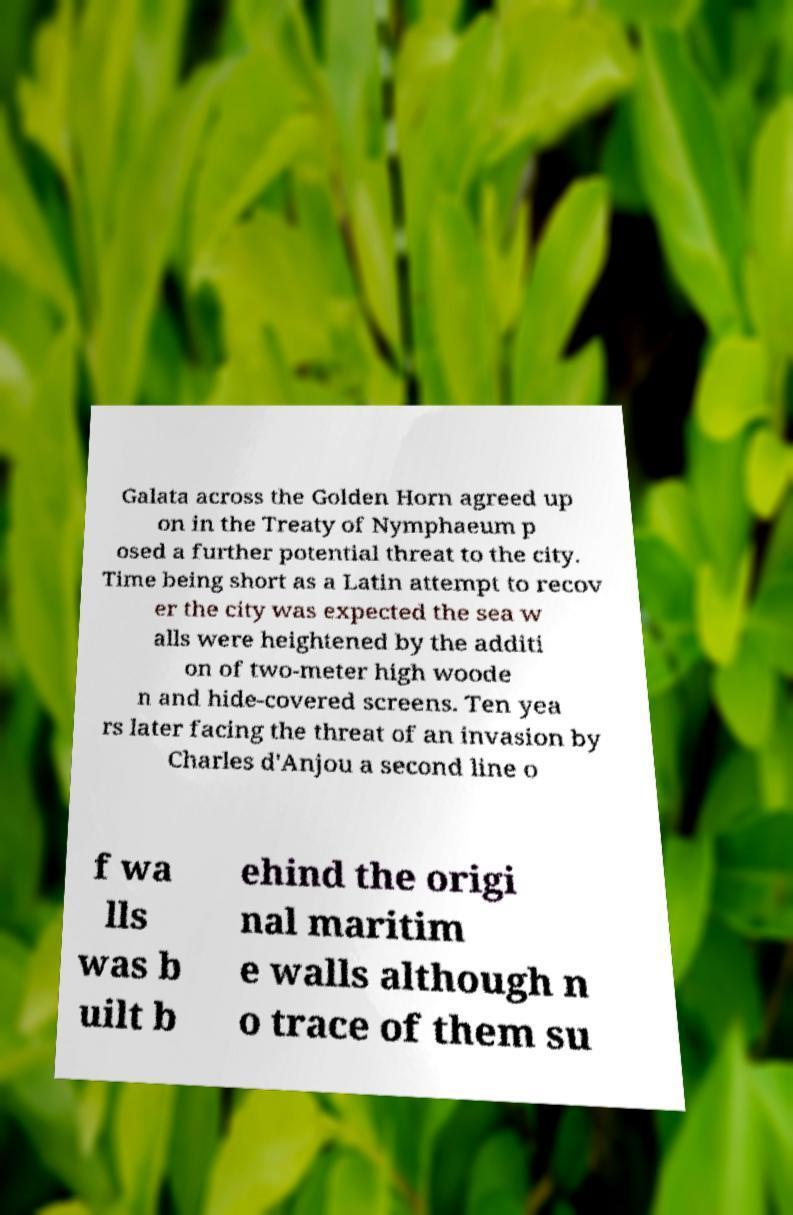I need the written content from this picture converted into text. Can you do that? Galata across the Golden Horn agreed up on in the Treaty of Nymphaeum p osed a further potential threat to the city. Time being short as a Latin attempt to recov er the city was expected the sea w alls were heightened by the additi on of two-meter high woode n and hide-covered screens. Ten yea rs later facing the threat of an invasion by Charles d'Anjou a second line o f wa lls was b uilt b ehind the origi nal maritim e walls although n o trace of them su 